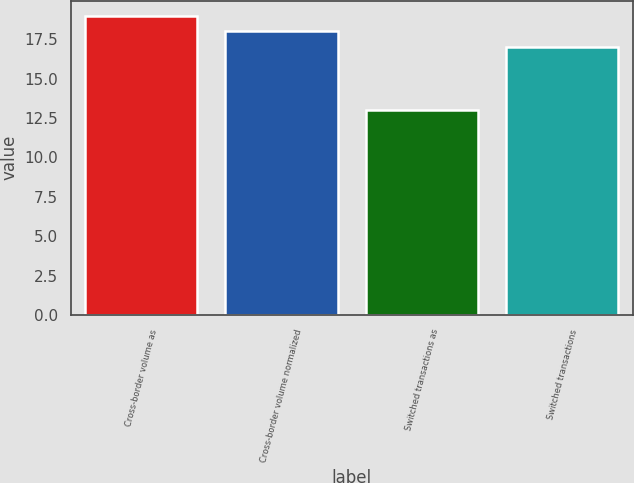Convert chart to OTSL. <chart><loc_0><loc_0><loc_500><loc_500><bar_chart><fcel>Cross-border volume as<fcel>Cross-border volume normalized<fcel>Switched transactions as<fcel>Switched transactions<nl><fcel>19<fcel>18<fcel>13<fcel>17<nl></chart> 